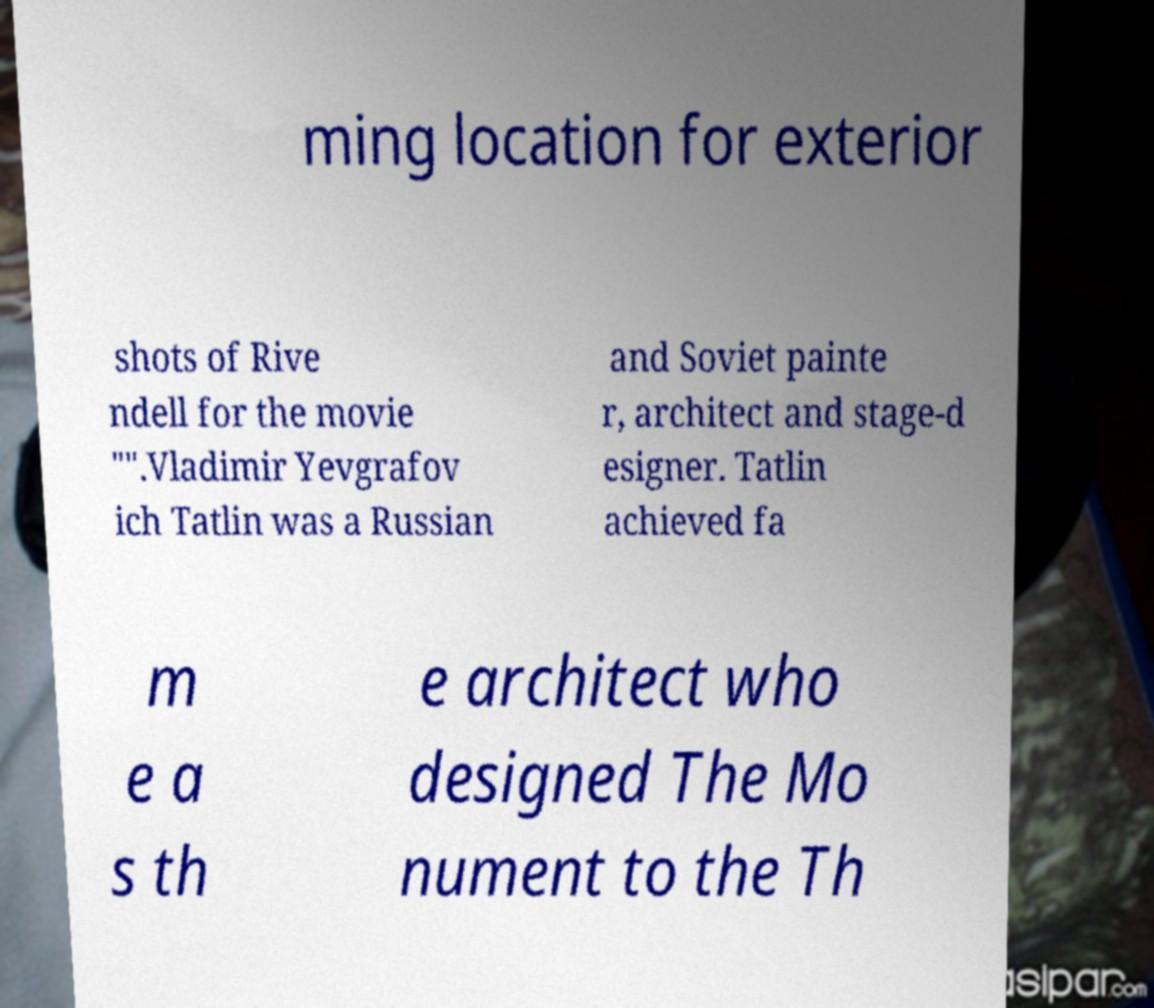Please read and relay the text visible in this image. What does it say? ming location for exterior shots of Rive ndell for the movie "".Vladimir Yevgrafov ich Tatlin was a Russian and Soviet painte r, architect and stage-d esigner. Tatlin achieved fa m e a s th e architect who designed The Mo nument to the Th 